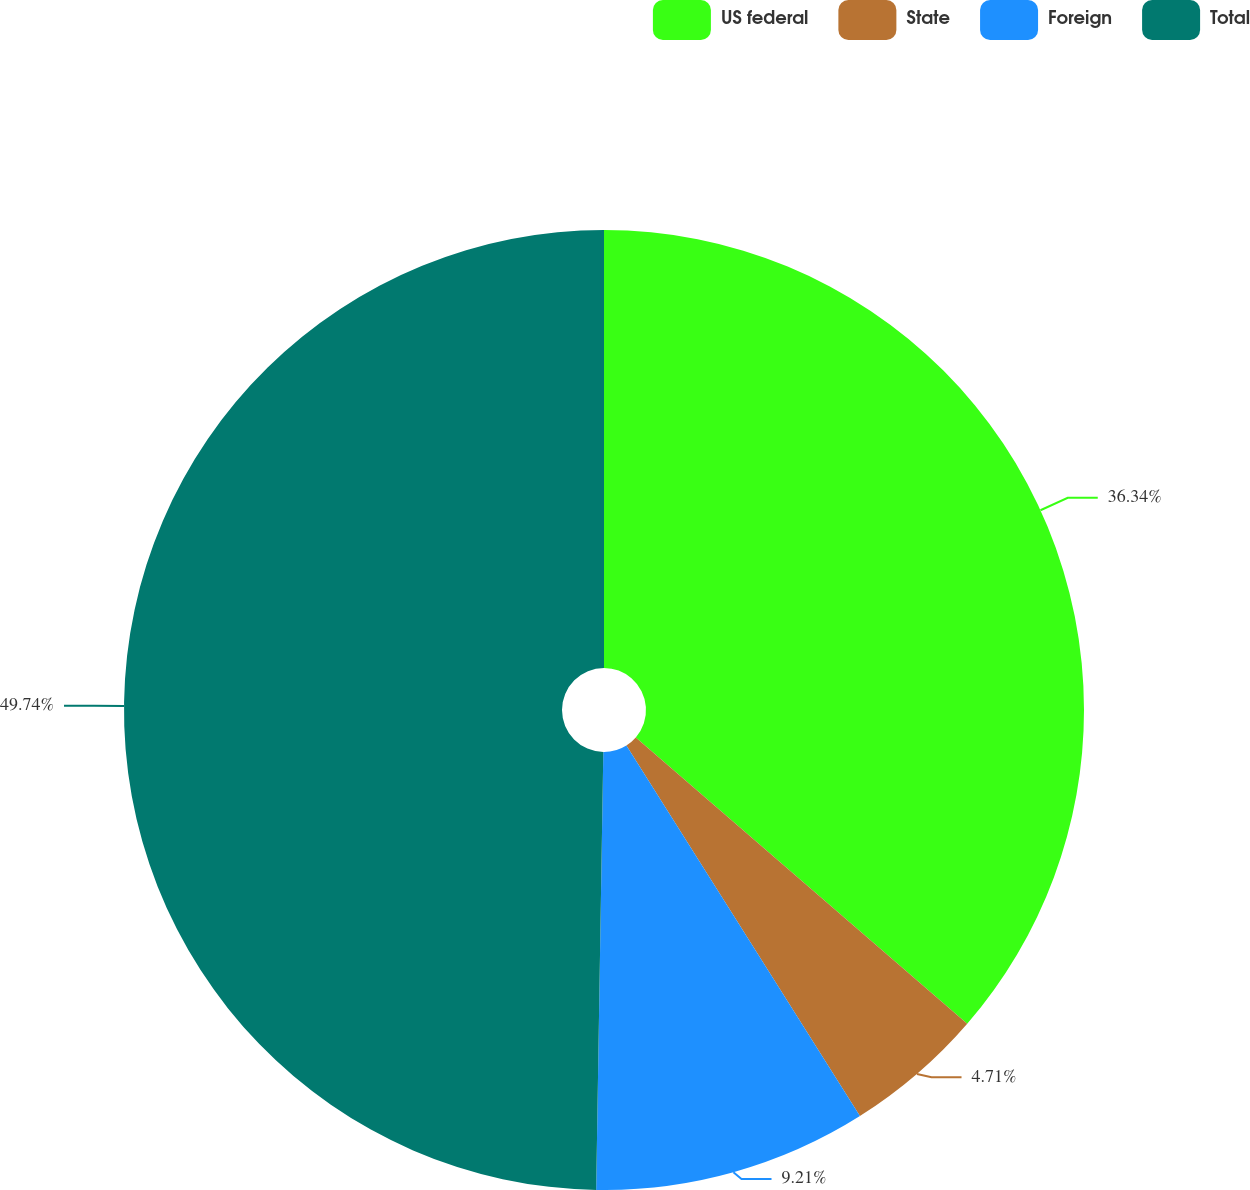Convert chart. <chart><loc_0><loc_0><loc_500><loc_500><pie_chart><fcel>US federal<fcel>State<fcel>Foreign<fcel>Total<nl><fcel>36.34%<fcel>4.71%<fcel>9.21%<fcel>49.74%<nl></chart> 